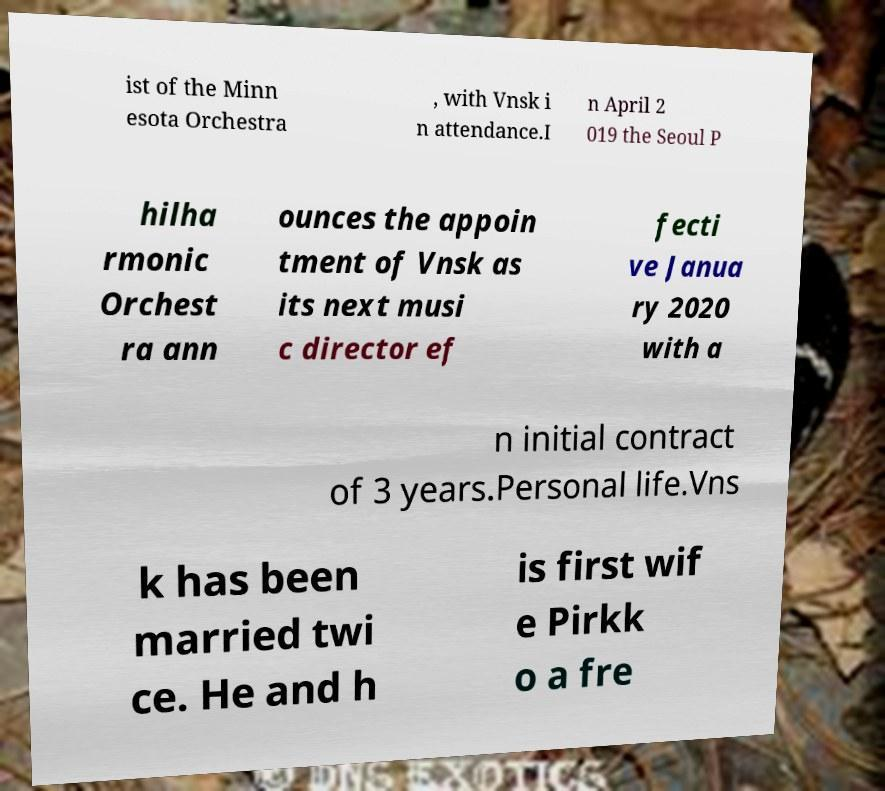Please identify and transcribe the text found in this image. ist of the Minn esota Orchestra , with Vnsk i n attendance.I n April 2 019 the Seoul P hilha rmonic Orchest ra ann ounces the appoin tment of Vnsk as its next musi c director ef fecti ve Janua ry 2020 with a n initial contract of 3 years.Personal life.Vns k has been married twi ce. He and h is first wif e Pirkk o a fre 